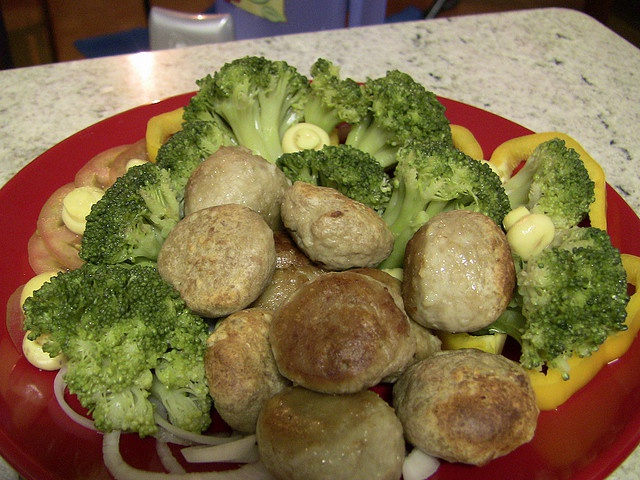Describe the objects in this image and their specific colors. I can see dining table in olive, black, maroon, and tan tones, broccoli in black, darkgreen, and olive tones, broccoli in black, darkgreen, and olive tones, broccoli in black, darkgreen, and olive tones, and broccoli in black and olive tones in this image. 